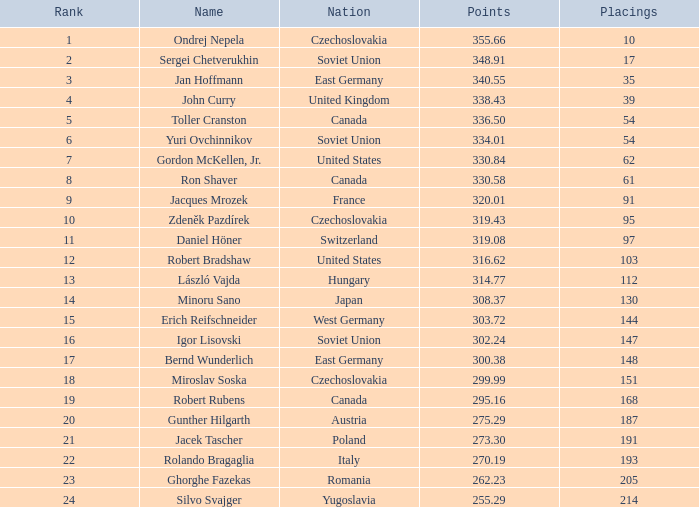How many rankings have points less than 33 1.0. 